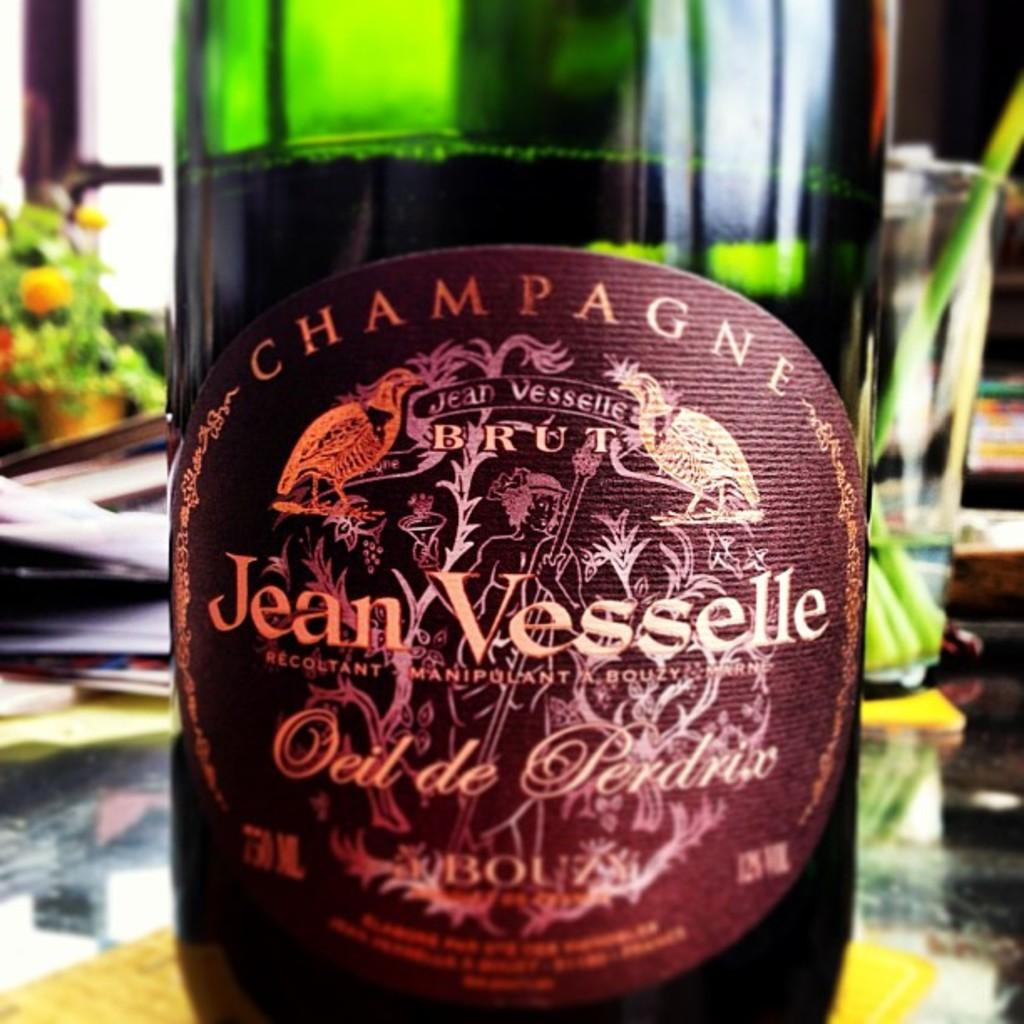What color is the bottle in the image? The bottle in the image is green. Is there any text or writing on the bottle? Yes, there is something written on the bottle. Where is the bottle located in the image? The bottle is placed on a table. What type of paste is being used to hold the crib together in the image? There is no crib or paste present in the image; it only features a green bottle on a table. 